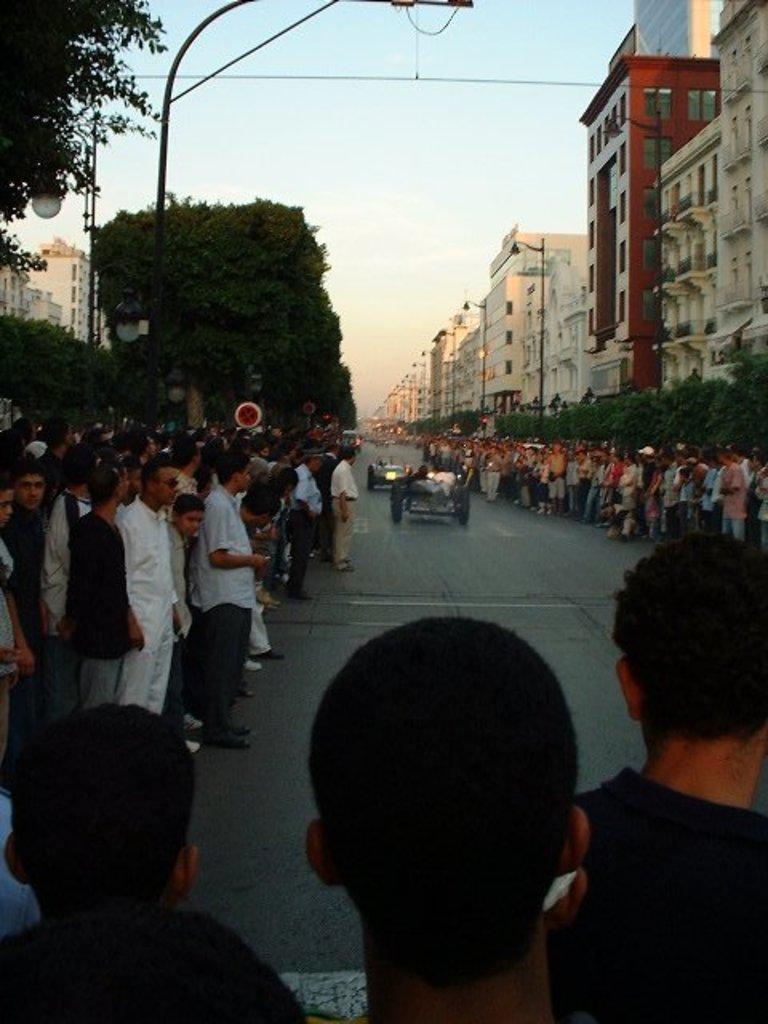Could you give a brief overview of what you see in this image? In the picture we can see a road on it, we can see two vehicles and round the road we can see many people are standing and watching the vehicles and behind them, we can see plants and some trees and buildings and in the background we can see the sky. 